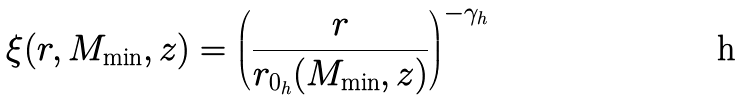<formula> <loc_0><loc_0><loc_500><loc_500>\xi ( r , M _ { \min } , z ) = \left ( \frac { r } { r _ { 0 _ { h } } ( M _ { \min } , z ) } \right ) ^ { - \gamma _ { h } }</formula> 